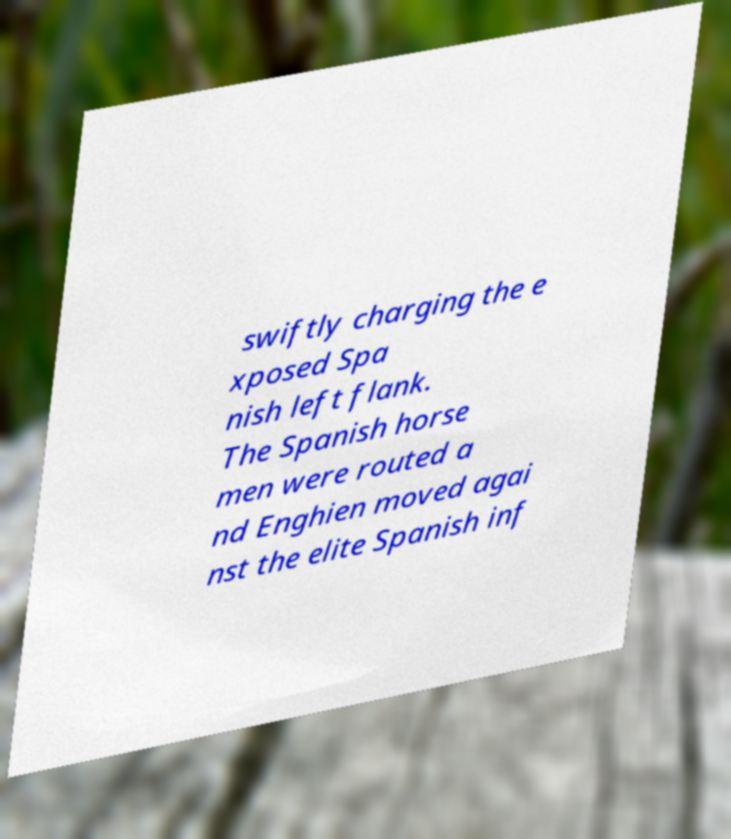What messages or text are displayed in this image? I need them in a readable, typed format. swiftly charging the e xposed Spa nish left flank. The Spanish horse men were routed a nd Enghien moved agai nst the elite Spanish inf 